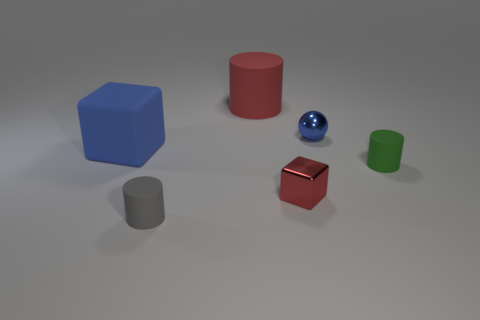Subtract all small rubber cylinders. How many cylinders are left? 1 Subtract 1 cylinders. How many cylinders are left? 2 Add 2 tiny blue rubber things. How many objects exist? 8 Subtract all spheres. How many objects are left? 5 Subtract all tiny metallic cubes. Subtract all small gray things. How many objects are left? 4 Add 2 small gray matte things. How many small gray matte things are left? 3 Add 2 blocks. How many blocks exist? 4 Subtract 0 green blocks. How many objects are left? 6 